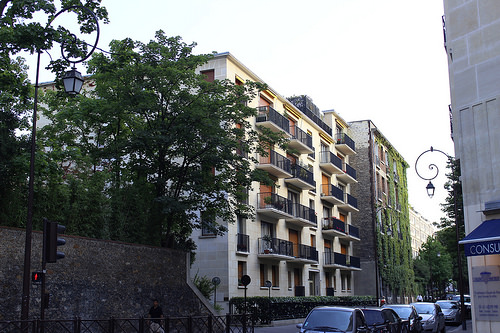<image>
Is the guy under the tree? Yes. The guy is positioned underneath the tree, with the tree above it in the vertical space. Where is the apartment in relation to the car? Is it in front of the car? No. The apartment is not in front of the car. The spatial positioning shows a different relationship between these objects. 